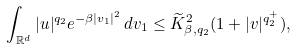<formula> <loc_0><loc_0><loc_500><loc_500>\int _ { \mathbb { R } ^ { d } } | u | ^ { q _ { 2 } } e ^ { - \beta | v _ { 1 } | ^ { 2 } } \, d v _ { 1 } \leq \widetilde { K } _ { \beta , q _ { 2 } } ^ { 2 } ( 1 + | v | ^ { q _ { 2 } ^ { + } } ) ,</formula> 